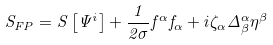Convert formula to latex. <formula><loc_0><loc_0><loc_500><loc_500>S _ { F P } = S \left [ \Psi ^ { i } \right ] + \frac { 1 } { 2 \sigma } f ^ { \alpha } f _ { \alpha } + i \zeta _ { \alpha } \Delta _ { \beta } ^ { \alpha } \eta ^ { \beta }</formula> 